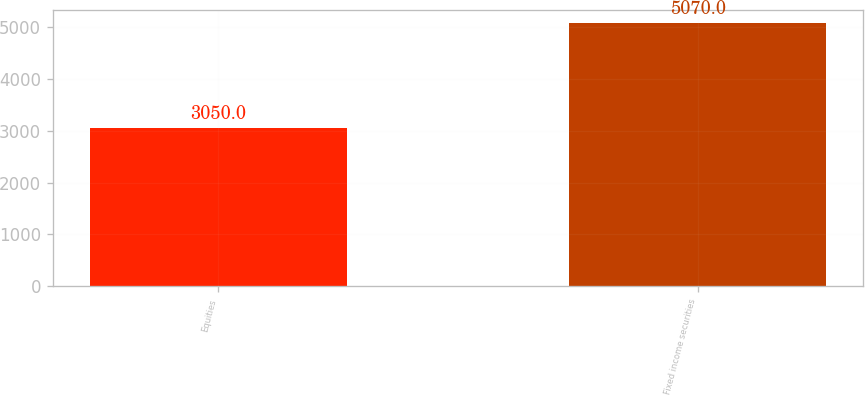Convert chart to OTSL. <chart><loc_0><loc_0><loc_500><loc_500><bar_chart><fcel>Equities<fcel>Fixed income securities<nl><fcel>3050<fcel>5070<nl></chart> 